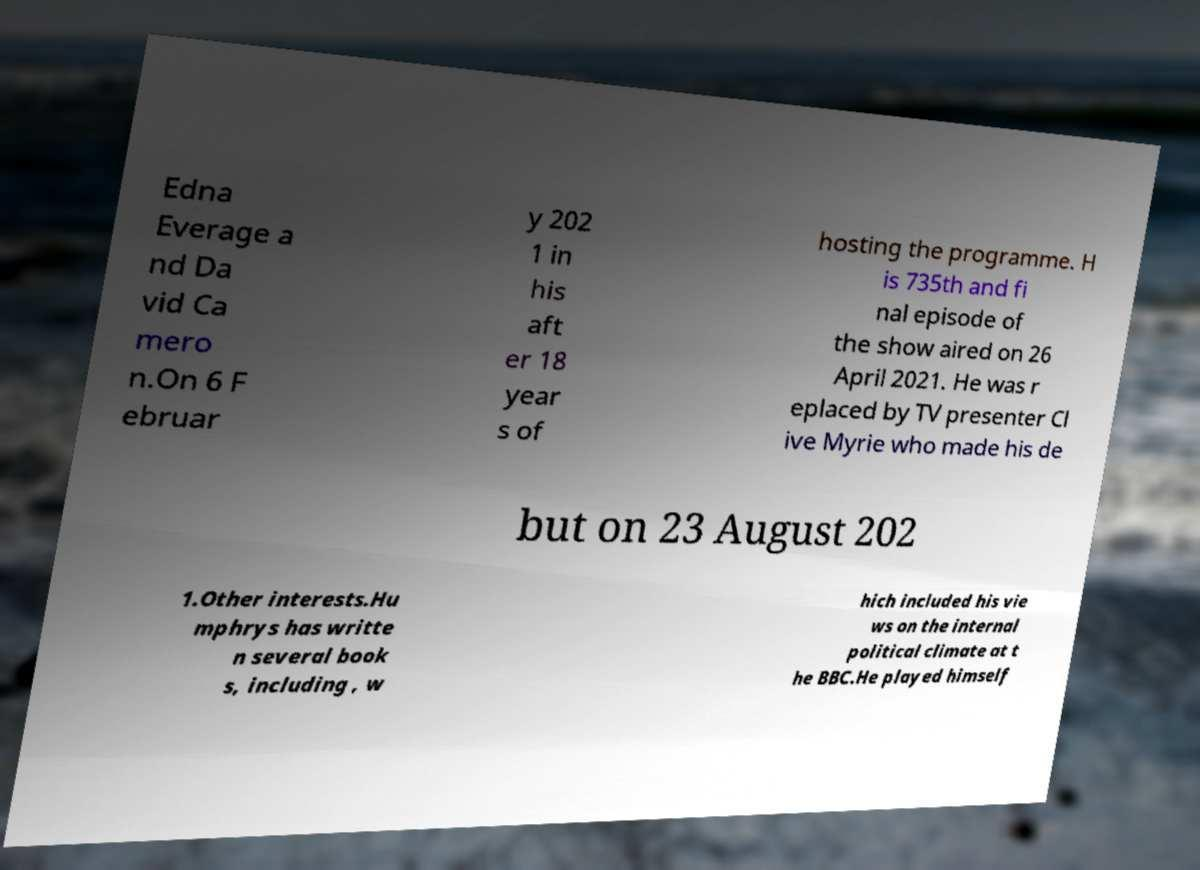Can you read and provide the text displayed in the image?This photo seems to have some interesting text. Can you extract and type it out for me? Edna Everage a nd Da vid Ca mero n.On 6 F ebruar y 202 1 in his aft er 18 year s of hosting the programme. H is 735th and fi nal episode of the show aired on 26 April 2021. He was r eplaced by TV presenter Cl ive Myrie who made his de but on 23 August 202 1.Other interests.Hu mphrys has writte n several book s, including , w hich included his vie ws on the internal political climate at t he BBC.He played himself 